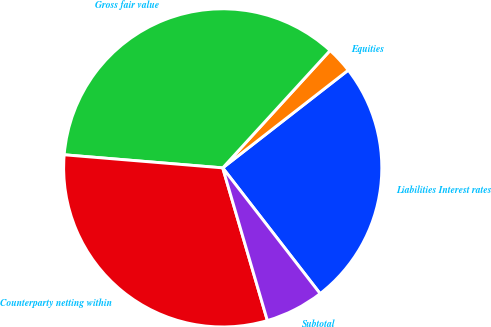Convert chart. <chart><loc_0><loc_0><loc_500><loc_500><pie_chart><fcel>Liabilities Interest rates<fcel>Equities<fcel>Gross fair value<fcel>Counterparty netting within<fcel>Subtotal<nl><fcel>25.04%<fcel>2.68%<fcel>35.48%<fcel>30.84%<fcel>5.96%<nl></chart> 